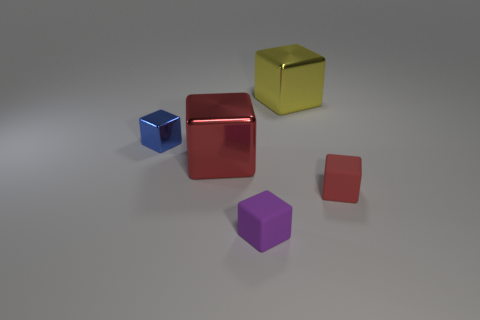Do the red cube behind the tiny red block and the tiny object that is behind the tiny red block have the same material?
Your response must be concise. Yes. What is the shape of the object on the left side of the big red shiny object?
Offer a terse response. Cube. Is the number of big red things less than the number of small objects?
Give a very brief answer. Yes. Is there a block that is on the right side of the blue metallic object on the left side of the big red object left of the small red matte thing?
Your response must be concise. Yes. How many rubber objects are yellow objects or tiny cubes?
Provide a short and direct response. 2. There is a tiny purple object; how many tiny blue cubes are in front of it?
Ensure brevity in your answer.  0. What number of tiny cubes are in front of the blue thing and left of the small red object?
Keep it short and to the point. 1. There is a red object that is made of the same material as the small blue block; what shape is it?
Your answer should be very brief. Cube. Is the size of the red object to the right of the big yellow shiny block the same as the rubber cube that is on the left side of the yellow metal object?
Your answer should be compact. Yes. There is a matte block to the left of the yellow block; what is its color?
Give a very brief answer. Purple. 